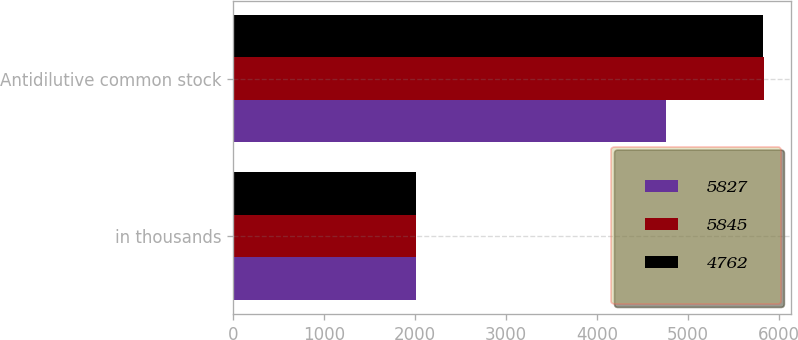Convert chart. <chart><loc_0><loc_0><loc_500><loc_500><stacked_bar_chart><ecel><fcel>in thousands<fcel>Antidilutive common stock<nl><fcel>5827<fcel>2012<fcel>4762<nl><fcel>5845<fcel>2011<fcel>5845<nl><fcel>4762<fcel>2010<fcel>5827<nl></chart> 